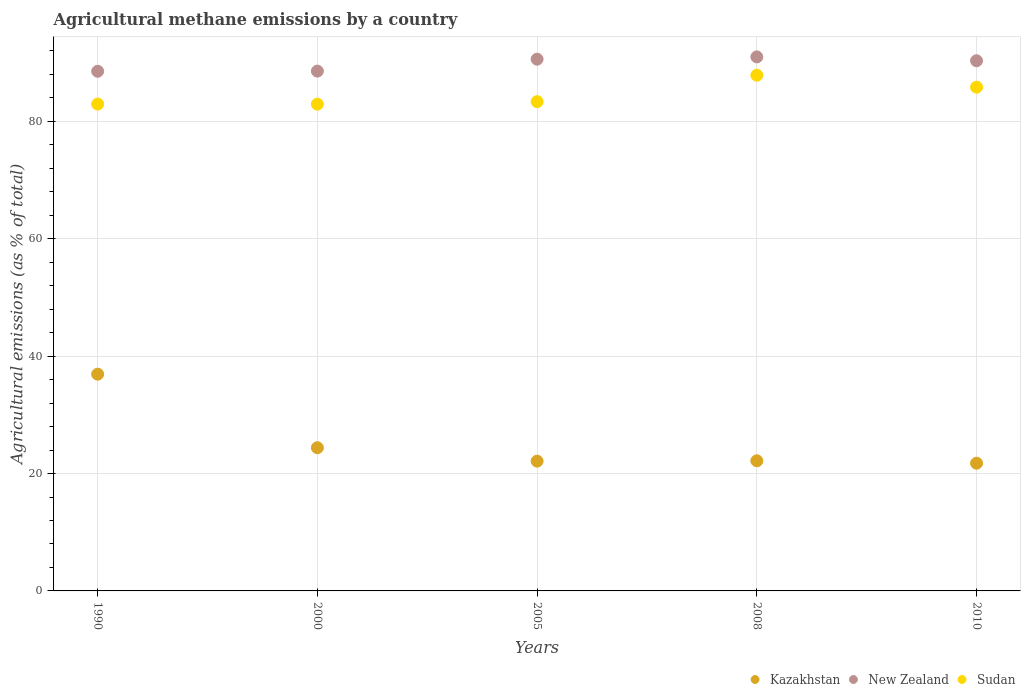How many different coloured dotlines are there?
Make the answer very short. 3. Is the number of dotlines equal to the number of legend labels?
Provide a short and direct response. Yes. What is the amount of agricultural methane emitted in New Zealand in 2005?
Give a very brief answer. 90.59. Across all years, what is the maximum amount of agricultural methane emitted in Kazakhstan?
Ensure brevity in your answer.  36.93. Across all years, what is the minimum amount of agricultural methane emitted in Sudan?
Provide a short and direct response. 82.93. In which year was the amount of agricultural methane emitted in Sudan maximum?
Your answer should be compact. 2008. In which year was the amount of agricultural methane emitted in New Zealand minimum?
Your answer should be very brief. 1990. What is the total amount of agricultural methane emitted in Sudan in the graph?
Provide a short and direct response. 422.93. What is the difference between the amount of agricultural methane emitted in New Zealand in 1990 and that in 2000?
Ensure brevity in your answer.  -0.03. What is the difference between the amount of agricultural methane emitted in Sudan in 2000 and the amount of agricultural methane emitted in Kazakhstan in 2005?
Offer a very short reply. 60.82. What is the average amount of agricultural methane emitted in Sudan per year?
Ensure brevity in your answer.  84.59. In the year 2000, what is the difference between the amount of agricultural methane emitted in New Zealand and amount of agricultural methane emitted in Kazakhstan?
Provide a succinct answer. 64.16. What is the ratio of the amount of agricultural methane emitted in Kazakhstan in 2000 to that in 2005?
Make the answer very short. 1.1. What is the difference between the highest and the second highest amount of agricultural methane emitted in Sudan?
Provide a succinct answer. 2.03. What is the difference between the highest and the lowest amount of agricultural methane emitted in New Zealand?
Keep it short and to the point. 2.45. In how many years, is the amount of agricultural methane emitted in New Zealand greater than the average amount of agricultural methane emitted in New Zealand taken over all years?
Offer a very short reply. 3. Is it the case that in every year, the sum of the amount of agricultural methane emitted in Sudan and amount of agricultural methane emitted in Kazakhstan  is greater than the amount of agricultural methane emitted in New Zealand?
Provide a succinct answer. Yes. Does the amount of agricultural methane emitted in Sudan monotonically increase over the years?
Keep it short and to the point. No. How many dotlines are there?
Your answer should be compact. 3. How many years are there in the graph?
Your answer should be compact. 5. What is the difference between two consecutive major ticks on the Y-axis?
Give a very brief answer. 20. Does the graph contain any zero values?
Offer a very short reply. No. Where does the legend appear in the graph?
Offer a terse response. Bottom right. What is the title of the graph?
Make the answer very short. Agricultural methane emissions by a country. What is the label or title of the X-axis?
Make the answer very short. Years. What is the label or title of the Y-axis?
Give a very brief answer. Agricultural emissions (as % of total). What is the Agricultural emissions (as % of total) of Kazakhstan in 1990?
Make the answer very short. 36.93. What is the Agricultural emissions (as % of total) in New Zealand in 1990?
Provide a short and direct response. 88.54. What is the Agricultural emissions (as % of total) of Sudan in 1990?
Your answer should be very brief. 82.95. What is the Agricultural emissions (as % of total) in Kazakhstan in 2000?
Your response must be concise. 24.4. What is the Agricultural emissions (as % of total) of New Zealand in 2000?
Your answer should be compact. 88.56. What is the Agricultural emissions (as % of total) in Sudan in 2000?
Give a very brief answer. 82.93. What is the Agricultural emissions (as % of total) of Kazakhstan in 2005?
Offer a terse response. 22.11. What is the Agricultural emissions (as % of total) of New Zealand in 2005?
Give a very brief answer. 90.59. What is the Agricultural emissions (as % of total) of Sudan in 2005?
Keep it short and to the point. 83.36. What is the Agricultural emissions (as % of total) in Kazakhstan in 2008?
Your answer should be compact. 22.17. What is the Agricultural emissions (as % of total) of New Zealand in 2008?
Your response must be concise. 90.99. What is the Agricultural emissions (as % of total) in Sudan in 2008?
Keep it short and to the point. 87.86. What is the Agricultural emissions (as % of total) of Kazakhstan in 2010?
Offer a terse response. 21.76. What is the Agricultural emissions (as % of total) in New Zealand in 2010?
Keep it short and to the point. 90.33. What is the Agricultural emissions (as % of total) of Sudan in 2010?
Offer a very short reply. 85.83. Across all years, what is the maximum Agricultural emissions (as % of total) in Kazakhstan?
Provide a succinct answer. 36.93. Across all years, what is the maximum Agricultural emissions (as % of total) in New Zealand?
Offer a terse response. 90.99. Across all years, what is the maximum Agricultural emissions (as % of total) in Sudan?
Your answer should be compact. 87.86. Across all years, what is the minimum Agricultural emissions (as % of total) of Kazakhstan?
Offer a terse response. 21.76. Across all years, what is the minimum Agricultural emissions (as % of total) in New Zealand?
Give a very brief answer. 88.54. Across all years, what is the minimum Agricultural emissions (as % of total) of Sudan?
Give a very brief answer. 82.93. What is the total Agricultural emissions (as % of total) of Kazakhstan in the graph?
Give a very brief answer. 127.37. What is the total Agricultural emissions (as % of total) of New Zealand in the graph?
Give a very brief answer. 449.01. What is the total Agricultural emissions (as % of total) of Sudan in the graph?
Your response must be concise. 422.93. What is the difference between the Agricultural emissions (as % of total) in Kazakhstan in 1990 and that in 2000?
Your answer should be compact. 12.53. What is the difference between the Agricultural emissions (as % of total) of New Zealand in 1990 and that in 2000?
Offer a terse response. -0.03. What is the difference between the Agricultural emissions (as % of total) of Sudan in 1990 and that in 2000?
Provide a short and direct response. 0.01. What is the difference between the Agricultural emissions (as % of total) of Kazakhstan in 1990 and that in 2005?
Keep it short and to the point. 14.82. What is the difference between the Agricultural emissions (as % of total) in New Zealand in 1990 and that in 2005?
Provide a succinct answer. -2.06. What is the difference between the Agricultural emissions (as % of total) in Sudan in 1990 and that in 2005?
Your answer should be very brief. -0.41. What is the difference between the Agricultural emissions (as % of total) of Kazakhstan in 1990 and that in 2008?
Give a very brief answer. 14.76. What is the difference between the Agricultural emissions (as % of total) of New Zealand in 1990 and that in 2008?
Your answer should be compact. -2.45. What is the difference between the Agricultural emissions (as % of total) in Sudan in 1990 and that in 2008?
Make the answer very short. -4.92. What is the difference between the Agricultural emissions (as % of total) in Kazakhstan in 1990 and that in 2010?
Make the answer very short. 15.17. What is the difference between the Agricultural emissions (as % of total) of New Zealand in 1990 and that in 2010?
Provide a short and direct response. -1.79. What is the difference between the Agricultural emissions (as % of total) in Sudan in 1990 and that in 2010?
Your response must be concise. -2.88. What is the difference between the Agricultural emissions (as % of total) in Kazakhstan in 2000 and that in 2005?
Ensure brevity in your answer.  2.29. What is the difference between the Agricultural emissions (as % of total) of New Zealand in 2000 and that in 2005?
Make the answer very short. -2.03. What is the difference between the Agricultural emissions (as % of total) of Sudan in 2000 and that in 2005?
Ensure brevity in your answer.  -0.43. What is the difference between the Agricultural emissions (as % of total) in Kazakhstan in 2000 and that in 2008?
Give a very brief answer. 2.23. What is the difference between the Agricultural emissions (as % of total) of New Zealand in 2000 and that in 2008?
Ensure brevity in your answer.  -2.42. What is the difference between the Agricultural emissions (as % of total) in Sudan in 2000 and that in 2008?
Provide a short and direct response. -4.93. What is the difference between the Agricultural emissions (as % of total) in Kazakhstan in 2000 and that in 2010?
Offer a terse response. 2.64. What is the difference between the Agricultural emissions (as % of total) in New Zealand in 2000 and that in 2010?
Make the answer very short. -1.77. What is the difference between the Agricultural emissions (as % of total) in Sudan in 2000 and that in 2010?
Provide a succinct answer. -2.9. What is the difference between the Agricultural emissions (as % of total) in Kazakhstan in 2005 and that in 2008?
Your answer should be compact. -0.06. What is the difference between the Agricultural emissions (as % of total) of New Zealand in 2005 and that in 2008?
Keep it short and to the point. -0.39. What is the difference between the Agricultural emissions (as % of total) of Sudan in 2005 and that in 2008?
Offer a terse response. -4.51. What is the difference between the Agricultural emissions (as % of total) in Kazakhstan in 2005 and that in 2010?
Ensure brevity in your answer.  0.36. What is the difference between the Agricultural emissions (as % of total) in New Zealand in 2005 and that in 2010?
Your answer should be compact. 0.27. What is the difference between the Agricultural emissions (as % of total) of Sudan in 2005 and that in 2010?
Ensure brevity in your answer.  -2.47. What is the difference between the Agricultural emissions (as % of total) in Kazakhstan in 2008 and that in 2010?
Provide a succinct answer. 0.41. What is the difference between the Agricultural emissions (as % of total) of New Zealand in 2008 and that in 2010?
Offer a very short reply. 0.66. What is the difference between the Agricultural emissions (as % of total) of Sudan in 2008 and that in 2010?
Provide a short and direct response. 2.03. What is the difference between the Agricultural emissions (as % of total) of Kazakhstan in 1990 and the Agricultural emissions (as % of total) of New Zealand in 2000?
Offer a very short reply. -51.63. What is the difference between the Agricultural emissions (as % of total) in Kazakhstan in 1990 and the Agricultural emissions (as % of total) in Sudan in 2000?
Your response must be concise. -46. What is the difference between the Agricultural emissions (as % of total) in New Zealand in 1990 and the Agricultural emissions (as % of total) in Sudan in 2000?
Keep it short and to the point. 5.6. What is the difference between the Agricultural emissions (as % of total) of Kazakhstan in 1990 and the Agricultural emissions (as % of total) of New Zealand in 2005?
Your response must be concise. -53.67. What is the difference between the Agricultural emissions (as % of total) of Kazakhstan in 1990 and the Agricultural emissions (as % of total) of Sudan in 2005?
Offer a terse response. -46.43. What is the difference between the Agricultural emissions (as % of total) in New Zealand in 1990 and the Agricultural emissions (as % of total) in Sudan in 2005?
Make the answer very short. 5.18. What is the difference between the Agricultural emissions (as % of total) of Kazakhstan in 1990 and the Agricultural emissions (as % of total) of New Zealand in 2008?
Give a very brief answer. -54.06. What is the difference between the Agricultural emissions (as % of total) of Kazakhstan in 1990 and the Agricultural emissions (as % of total) of Sudan in 2008?
Your answer should be compact. -50.94. What is the difference between the Agricultural emissions (as % of total) in New Zealand in 1990 and the Agricultural emissions (as % of total) in Sudan in 2008?
Offer a very short reply. 0.67. What is the difference between the Agricultural emissions (as % of total) of Kazakhstan in 1990 and the Agricultural emissions (as % of total) of New Zealand in 2010?
Provide a succinct answer. -53.4. What is the difference between the Agricultural emissions (as % of total) in Kazakhstan in 1990 and the Agricultural emissions (as % of total) in Sudan in 2010?
Your response must be concise. -48.9. What is the difference between the Agricultural emissions (as % of total) in New Zealand in 1990 and the Agricultural emissions (as % of total) in Sudan in 2010?
Offer a terse response. 2.71. What is the difference between the Agricultural emissions (as % of total) of Kazakhstan in 2000 and the Agricultural emissions (as % of total) of New Zealand in 2005?
Your answer should be compact. -66.19. What is the difference between the Agricultural emissions (as % of total) in Kazakhstan in 2000 and the Agricultural emissions (as % of total) in Sudan in 2005?
Make the answer very short. -58.96. What is the difference between the Agricultural emissions (as % of total) in New Zealand in 2000 and the Agricultural emissions (as % of total) in Sudan in 2005?
Your answer should be compact. 5.2. What is the difference between the Agricultural emissions (as % of total) in Kazakhstan in 2000 and the Agricultural emissions (as % of total) in New Zealand in 2008?
Ensure brevity in your answer.  -66.58. What is the difference between the Agricultural emissions (as % of total) of Kazakhstan in 2000 and the Agricultural emissions (as % of total) of Sudan in 2008?
Your response must be concise. -63.46. What is the difference between the Agricultural emissions (as % of total) in New Zealand in 2000 and the Agricultural emissions (as % of total) in Sudan in 2008?
Make the answer very short. 0.7. What is the difference between the Agricultural emissions (as % of total) in Kazakhstan in 2000 and the Agricultural emissions (as % of total) in New Zealand in 2010?
Offer a terse response. -65.93. What is the difference between the Agricultural emissions (as % of total) in Kazakhstan in 2000 and the Agricultural emissions (as % of total) in Sudan in 2010?
Provide a short and direct response. -61.43. What is the difference between the Agricultural emissions (as % of total) in New Zealand in 2000 and the Agricultural emissions (as % of total) in Sudan in 2010?
Ensure brevity in your answer.  2.73. What is the difference between the Agricultural emissions (as % of total) of Kazakhstan in 2005 and the Agricultural emissions (as % of total) of New Zealand in 2008?
Provide a succinct answer. -68.87. What is the difference between the Agricultural emissions (as % of total) in Kazakhstan in 2005 and the Agricultural emissions (as % of total) in Sudan in 2008?
Make the answer very short. -65.75. What is the difference between the Agricultural emissions (as % of total) of New Zealand in 2005 and the Agricultural emissions (as % of total) of Sudan in 2008?
Offer a very short reply. 2.73. What is the difference between the Agricultural emissions (as % of total) of Kazakhstan in 2005 and the Agricultural emissions (as % of total) of New Zealand in 2010?
Your answer should be very brief. -68.22. What is the difference between the Agricultural emissions (as % of total) of Kazakhstan in 2005 and the Agricultural emissions (as % of total) of Sudan in 2010?
Provide a short and direct response. -63.72. What is the difference between the Agricultural emissions (as % of total) of New Zealand in 2005 and the Agricultural emissions (as % of total) of Sudan in 2010?
Give a very brief answer. 4.77. What is the difference between the Agricultural emissions (as % of total) in Kazakhstan in 2008 and the Agricultural emissions (as % of total) in New Zealand in 2010?
Your answer should be compact. -68.16. What is the difference between the Agricultural emissions (as % of total) in Kazakhstan in 2008 and the Agricultural emissions (as % of total) in Sudan in 2010?
Your answer should be very brief. -63.66. What is the difference between the Agricultural emissions (as % of total) in New Zealand in 2008 and the Agricultural emissions (as % of total) in Sudan in 2010?
Give a very brief answer. 5.16. What is the average Agricultural emissions (as % of total) in Kazakhstan per year?
Keep it short and to the point. 25.47. What is the average Agricultural emissions (as % of total) in New Zealand per year?
Your answer should be compact. 89.8. What is the average Agricultural emissions (as % of total) in Sudan per year?
Your response must be concise. 84.59. In the year 1990, what is the difference between the Agricultural emissions (as % of total) in Kazakhstan and Agricultural emissions (as % of total) in New Zealand?
Make the answer very short. -51.61. In the year 1990, what is the difference between the Agricultural emissions (as % of total) of Kazakhstan and Agricultural emissions (as % of total) of Sudan?
Make the answer very short. -46.02. In the year 1990, what is the difference between the Agricultural emissions (as % of total) of New Zealand and Agricultural emissions (as % of total) of Sudan?
Offer a very short reply. 5.59. In the year 2000, what is the difference between the Agricultural emissions (as % of total) of Kazakhstan and Agricultural emissions (as % of total) of New Zealand?
Offer a very short reply. -64.16. In the year 2000, what is the difference between the Agricultural emissions (as % of total) in Kazakhstan and Agricultural emissions (as % of total) in Sudan?
Provide a short and direct response. -58.53. In the year 2000, what is the difference between the Agricultural emissions (as % of total) of New Zealand and Agricultural emissions (as % of total) of Sudan?
Provide a short and direct response. 5.63. In the year 2005, what is the difference between the Agricultural emissions (as % of total) in Kazakhstan and Agricultural emissions (as % of total) in New Zealand?
Provide a short and direct response. -68.48. In the year 2005, what is the difference between the Agricultural emissions (as % of total) of Kazakhstan and Agricultural emissions (as % of total) of Sudan?
Offer a terse response. -61.25. In the year 2005, what is the difference between the Agricultural emissions (as % of total) of New Zealand and Agricultural emissions (as % of total) of Sudan?
Give a very brief answer. 7.24. In the year 2008, what is the difference between the Agricultural emissions (as % of total) of Kazakhstan and Agricultural emissions (as % of total) of New Zealand?
Make the answer very short. -68.81. In the year 2008, what is the difference between the Agricultural emissions (as % of total) in Kazakhstan and Agricultural emissions (as % of total) in Sudan?
Give a very brief answer. -65.69. In the year 2008, what is the difference between the Agricultural emissions (as % of total) in New Zealand and Agricultural emissions (as % of total) in Sudan?
Offer a terse response. 3.12. In the year 2010, what is the difference between the Agricultural emissions (as % of total) in Kazakhstan and Agricultural emissions (as % of total) in New Zealand?
Provide a short and direct response. -68.57. In the year 2010, what is the difference between the Agricultural emissions (as % of total) of Kazakhstan and Agricultural emissions (as % of total) of Sudan?
Provide a short and direct response. -64.07. In the year 2010, what is the difference between the Agricultural emissions (as % of total) in New Zealand and Agricultural emissions (as % of total) in Sudan?
Provide a short and direct response. 4.5. What is the ratio of the Agricultural emissions (as % of total) of Kazakhstan in 1990 to that in 2000?
Give a very brief answer. 1.51. What is the ratio of the Agricultural emissions (as % of total) in Kazakhstan in 1990 to that in 2005?
Ensure brevity in your answer.  1.67. What is the ratio of the Agricultural emissions (as % of total) in New Zealand in 1990 to that in 2005?
Keep it short and to the point. 0.98. What is the ratio of the Agricultural emissions (as % of total) in Kazakhstan in 1990 to that in 2008?
Ensure brevity in your answer.  1.67. What is the ratio of the Agricultural emissions (as % of total) in New Zealand in 1990 to that in 2008?
Provide a short and direct response. 0.97. What is the ratio of the Agricultural emissions (as % of total) in Sudan in 1990 to that in 2008?
Offer a very short reply. 0.94. What is the ratio of the Agricultural emissions (as % of total) of Kazakhstan in 1990 to that in 2010?
Provide a succinct answer. 1.7. What is the ratio of the Agricultural emissions (as % of total) of New Zealand in 1990 to that in 2010?
Your answer should be very brief. 0.98. What is the ratio of the Agricultural emissions (as % of total) of Sudan in 1990 to that in 2010?
Your answer should be very brief. 0.97. What is the ratio of the Agricultural emissions (as % of total) of Kazakhstan in 2000 to that in 2005?
Your answer should be very brief. 1.1. What is the ratio of the Agricultural emissions (as % of total) in New Zealand in 2000 to that in 2005?
Your response must be concise. 0.98. What is the ratio of the Agricultural emissions (as % of total) in Kazakhstan in 2000 to that in 2008?
Ensure brevity in your answer.  1.1. What is the ratio of the Agricultural emissions (as % of total) of New Zealand in 2000 to that in 2008?
Offer a terse response. 0.97. What is the ratio of the Agricultural emissions (as % of total) of Sudan in 2000 to that in 2008?
Offer a terse response. 0.94. What is the ratio of the Agricultural emissions (as % of total) in Kazakhstan in 2000 to that in 2010?
Provide a succinct answer. 1.12. What is the ratio of the Agricultural emissions (as % of total) in New Zealand in 2000 to that in 2010?
Keep it short and to the point. 0.98. What is the ratio of the Agricultural emissions (as % of total) in Sudan in 2000 to that in 2010?
Your answer should be compact. 0.97. What is the ratio of the Agricultural emissions (as % of total) in Kazakhstan in 2005 to that in 2008?
Your answer should be compact. 1. What is the ratio of the Agricultural emissions (as % of total) in Sudan in 2005 to that in 2008?
Provide a short and direct response. 0.95. What is the ratio of the Agricultural emissions (as % of total) in Kazakhstan in 2005 to that in 2010?
Make the answer very short. 1.02. What is the ratio of the Agricultural emissions (as % of total) of Sudan in 2005 to that in 2010?
Your answer should be very brief. 0.97. What is the ratio of the Agricultural emissions (as % of total) in Kazakhstan in 2008 to that in 2010?
Your answer should be very brief. 1.02. What is the ratio of the Agricultural emissions (as % of total) of New Zealand in 2008 to that in 2010?
Your answer should be very brief. 1.01. What is the ratio of the Agricultural emissions (as % of total) of Sudan in 2008 to that in 2010?
Your answer should be compact. 1.02. What is the difference between the highest and the second highest Agricultural emissions (as % of total) in Kazakhstan?
Give a very brief answer. 12.53. What is the difference between the highest and the second highest Agricultural emissions (as % of total) in New Zealand?
Your answer should be very brief. 0.39. What is the difference between the highest and the second highest Agricultural emissions (as % of total) in Sudan?
Ensure brevity in your answer.  2.03. What is the difference between the highest and the lowest Agricultural emissions (as % of total) in Kazakhstan?
Offer a terse response. 15.17. What is the difference between the highest and the lowest Agricultural emissions (as % of total) in New Zealand?
Offer a very short reply. 2.45. What is the difference between the highest and the lowest Agricultural emissions (as % of total) of Sudan?
Offer a terse response. 4.93. 